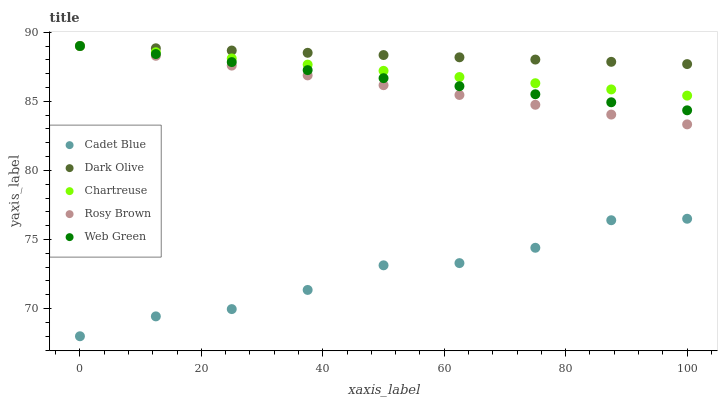Does Cadet Blue have the minimum area under the curve?
Answer yes or no. Yes. Does Dark Olive have the maximum area under the curve?
Answer yes or no. Yes. Does Chartreuse have the minimum area under the curve?
Answer yes or no. No. Does Chartreuse have the maximum area under the curve?
Answer yes or no. No. Is Dark Olive the smoothest?
Answer yes or no. Yes. Is Cadet Blue the roughest?
Answer yes or no. Yes. Is Chartreuse the smoothest?
Answer yes or no. No. Is Chartreuse the roughest?
Answer yes or no. No. Does Cadet Blue have the lowest value?
Answer yes or no. Yes. Does Chartreuse have the lowest value?
Answer yes or no. No. Does Rosy Brown have the highest value?
Answer yes or no. Yes. Does Cadet Blue have the highest value?
Answer yes or no. No. Is Cadet Blue less than Chartreuse?
Answer yes or no. Yes. Is Rosy Brown greater than Cadet Blue?
Answer yes or no. Yes. Does Dark Olive intersect Rosy Brown?
Answer yes or no. Yes. Is Dark Olive less than Rosy Brown?
Answer yes or no. No. Is Dark Olive greater than Rosy Brown?
Answer yes or no. No. Does Cadet Blue intersect Chartreuse?
Answer yes or no. No. 